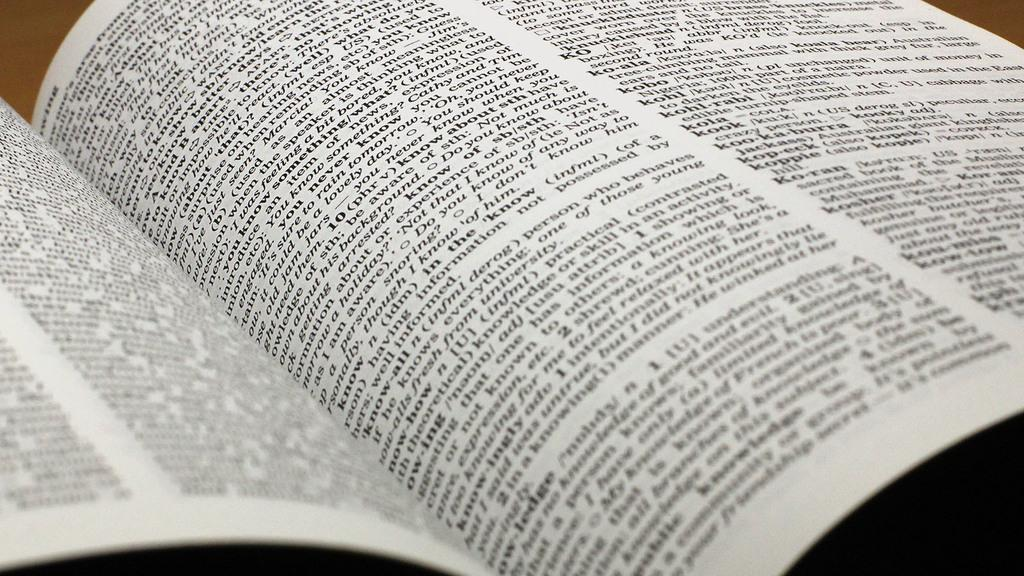<image>
Render a clear and concise summary of the photo. A book open and covered in dense, blurry text that includes "Not that I know of (ie Not as..." in the middle. 